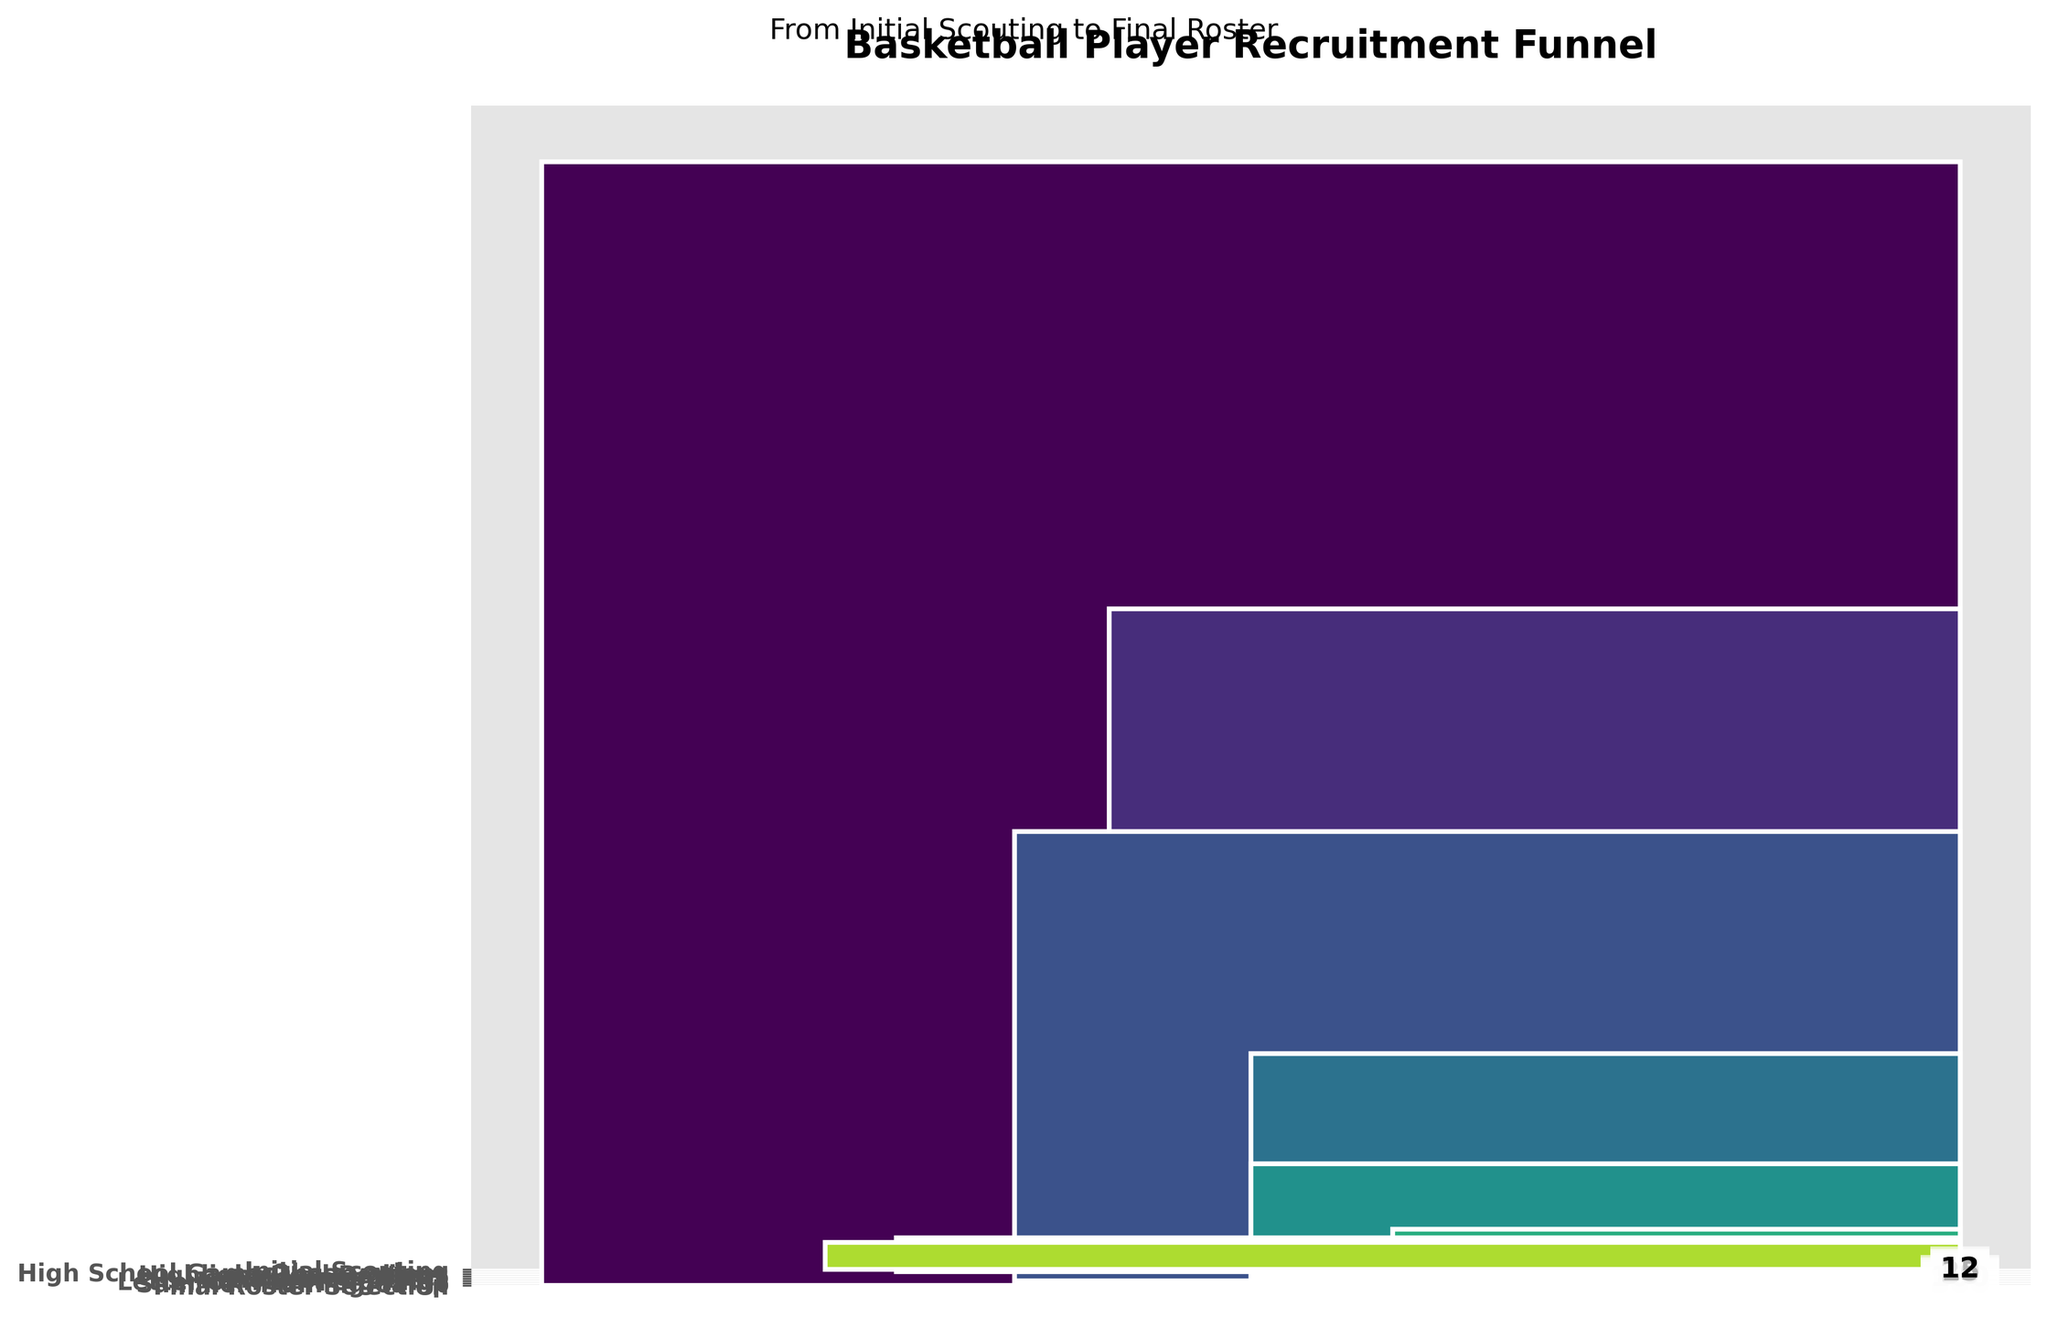What is the title of the chart? The title of the chart is prominently displayed at the top.
Answer: Basketball Player Recruitment Funnel How many stages are there in the recruitment process? The funnel chart shows a series of stacked bars, each representing a stage in the recruitment process. Counting the bars gives the number of stages.
Answer: 8 How many players reach the Final Roster Selection? The last bar in the funnel chart represents the Final Roster Selection stage, and the number of players is labeled within it.
Answer: 12 What is the value for the High School Game Observations stage? Identify the bar labeled as High School Game Observations and read the number inside it.
Answer: 300 By how many players does the number decrease from Initial Scouting to Scholarship Offers? Subtract the number of players at the Scholarship Offers stage from the number at the Initial Scouting stage: 500 - 50.
Answer: 450 What is the percentage of players who make it from Campus Visits to Letter of Intent Signings? Divide the number of players at the Letter of Intent Signings stage by the number at the Campus Visits stage and multiply by 100: (20 / 100) * 100.
Answer: 20% Which stage has the steepest drop-off in player numbers? Compare the differences in player numbers between consecutive stages to find the greatest difference. The steepest drop-off is from Highlight Reel Reviews to Campus Visits (200 - 100).
Answer: Highlight Reel Reviews to Campus Visits Which stage directly follows the Highlight Reel Reviews stage? Locate the Highlight Reel Reviews stage and identify the next stage below it in the funnel.
Answer: Campus Visits What is the total number of players from Scholarship Offers, Letter of Intent Signings, and Final Roster Selection? Add the numbers from each of these stages: 50 (Scholarship Offers) + 20 (Letter of Intent Signings) + 12 (Final Roster Selection).
Answer: 82 What is the overall attrition rate from Initial Scouting to Final Roster Selection? Calculate the difference in players from Initial Scouting to Final Roster Selection and divide by the number at Initial Scouting, then multiply by 100: ((500 - 12) / 500) * 100.
Answer: 97.6% 